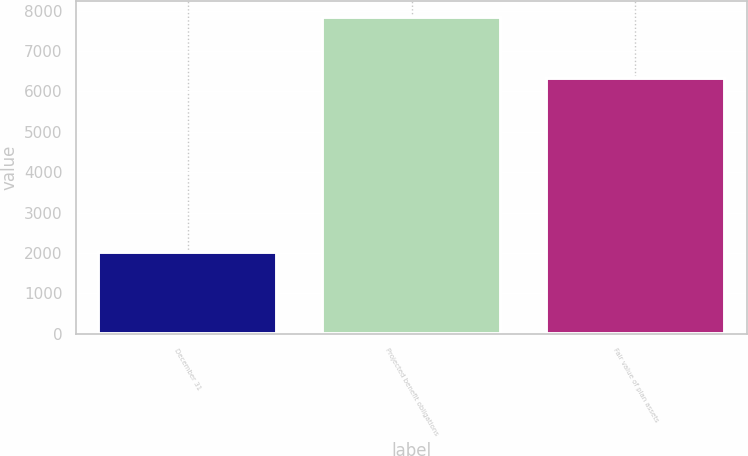Convert chart. <chart><loc_0><loc_0><loc_500><loc_500><bar_chart><fcel>December 31<fcel>Projected benefit obligations<fcel>Fair value of plan assets<nl><fcel>2017<fcel>7833<fcel>6330<nl></chart> 